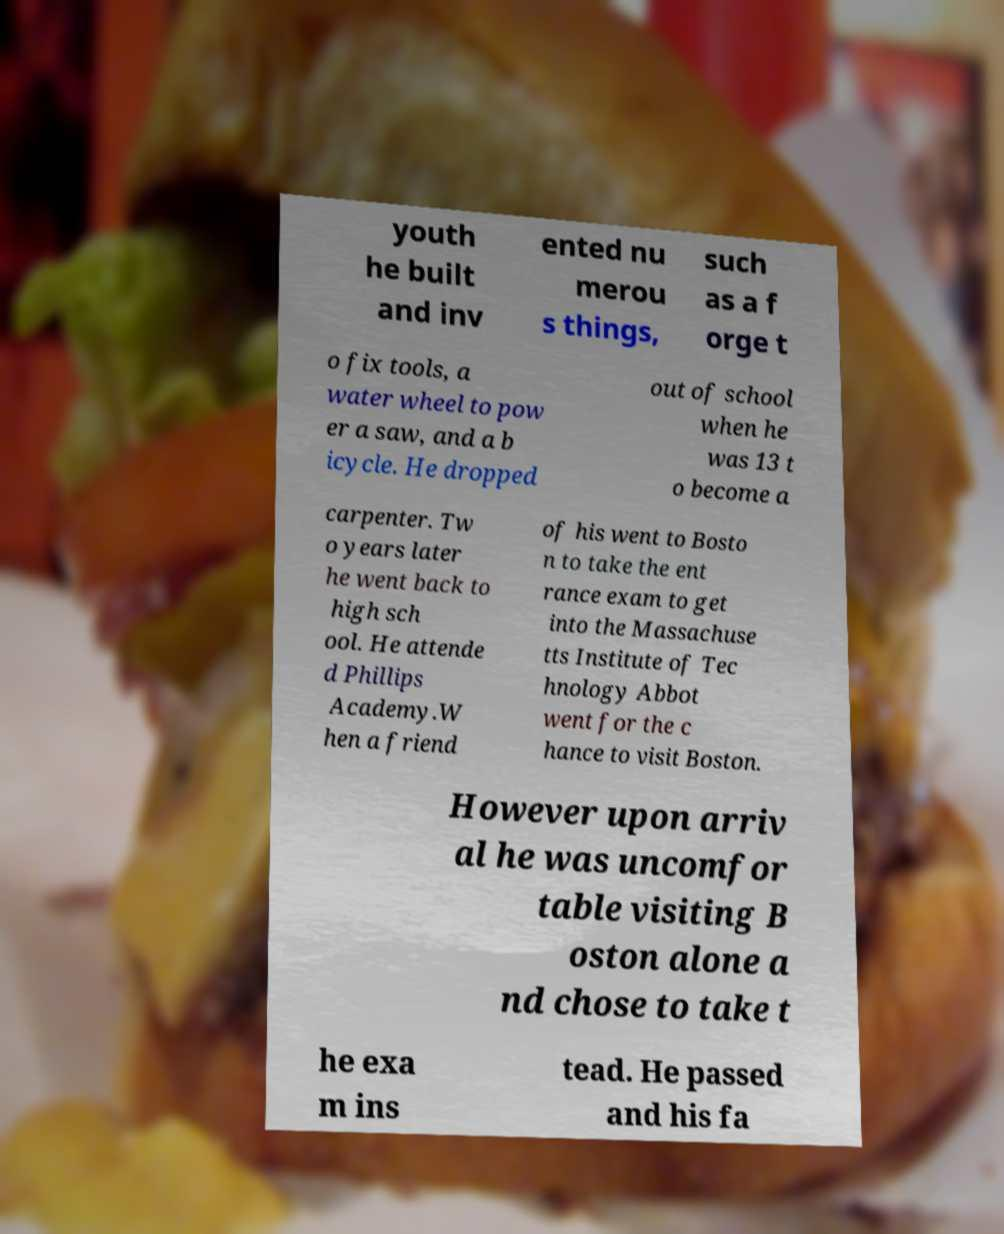Could you assist in decoding the text presented in this image and type it out clearly? youth he built and inv ented nu merou s things, such as a f orge t o fix tools, a water wheel to pow er a saw, and a b icycle. He dropped out of school when he was 13 t o become a carpenter. Tw o years later he went back to high sch ool. He attende d Phillips Academy.W hen a friend of his went to Bosto n to take the ent rance exam to get into the Massachuse tts Institute of Tec hnology Abbot went for the c hance to visit Boston. However upon arriv al he was uncomfor table visiting B oston alone a nd chose to take t he exa m ins tead. He passed and his fa 